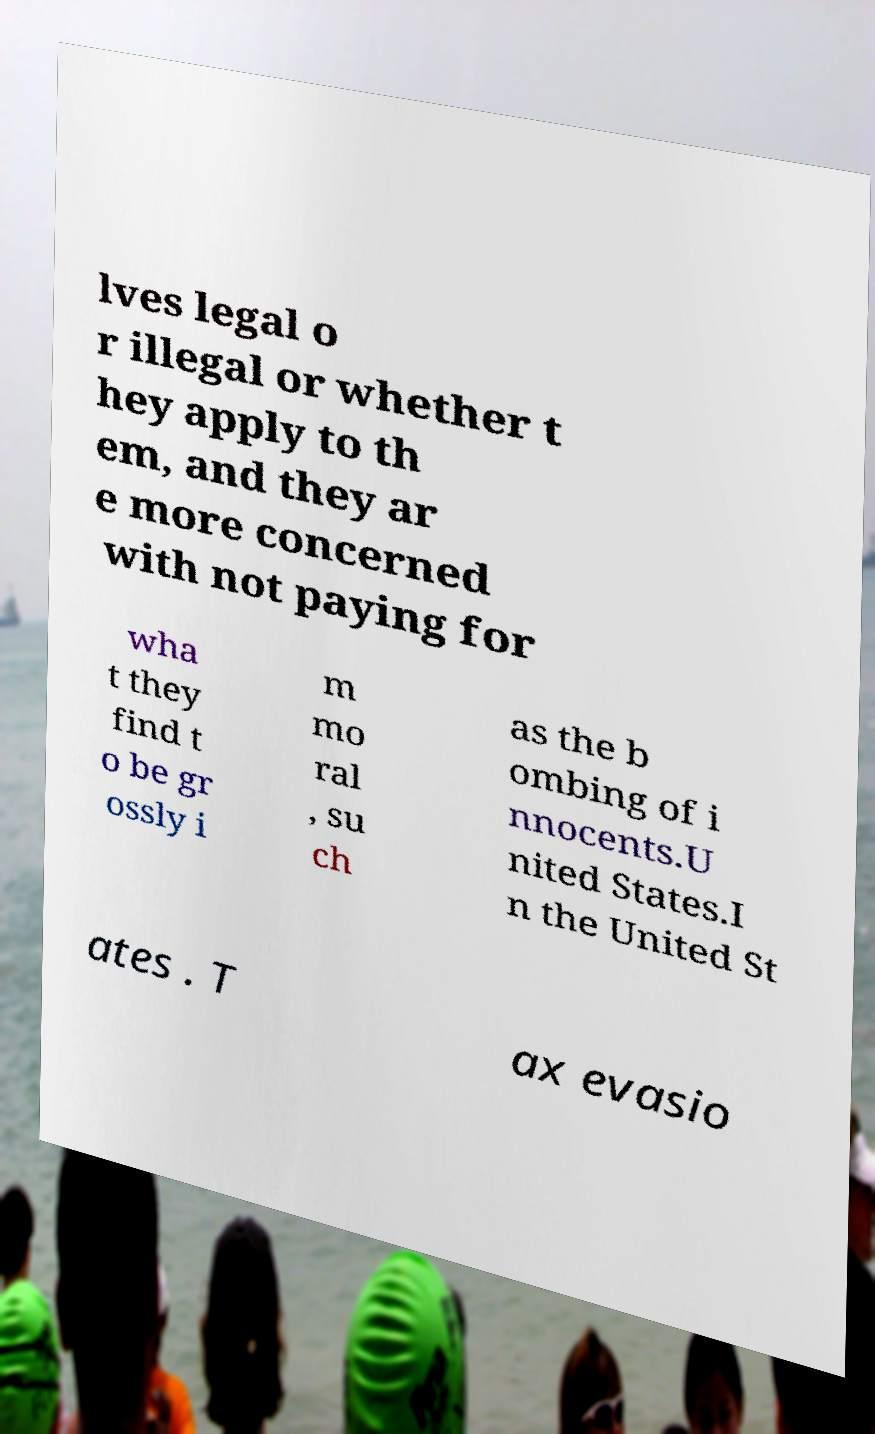There's text embedded in this image that I need extracted. Can you transcribe it verbatim? lves legal o r illegal or whether t hey apply to th em, and they ar e more concerned with not paying for wha t they find t o be gr ossly i m mo ral , su ch as the b ombing of i nnocents.U nited States.I n the United St ates . T ax evasio 